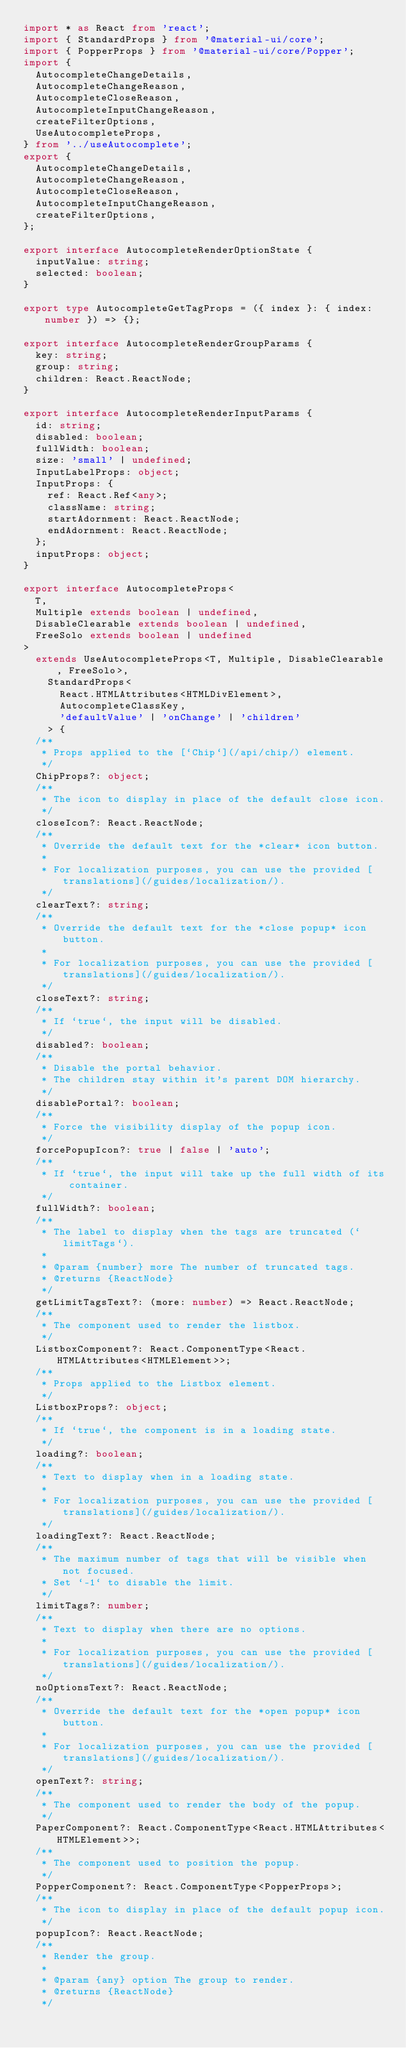Convert code to text. <code><loc_0><loc_0><loc_500><loc_500><_TypeScript_>import * as React from 'react';
import { StandardProps } from '@material-ui/core';
import { PopperProps } from '@material-ui/core/Popper';
import {
  AutocompleteChangeDetails,
  AutocompleteChangeReason,
  AutocompleteCloseReason,
  AutocompleteInputChangeReason,
  createFilterOptions,
  UseAutocompleteProps,
} from '../useAutocomplete';
export {
  AutocompleteChangeDetails,
  AutocompleteChangeReason,
  AutocompleteCloseReason,
  AutocompleteInputChangeReason,
  createFilterOptions,
};

export interface AutocompleteRenderOptionState {
  inputValue: string;
  selected: boolean;
}

export type AutocompleteGetTagProps = ({ index }: { index: number }) => {};

export interface AutocompleteRenderGroupParams {
  key: string;
  group: string;
  children: React.ReactNode;
}

export interface AutocompleteRenderInputParams {
  id: string;
  disabled: boolean;
  fullWidth: boolean;
  size: 'small' | undefined;
  InputLabelProps: object;
  InputProps: {
    ref: React.Ref<any>;
    className: string;
    startAdornment: React.ReactNode;
    endAdornment: React.ReactNode;
  };
  inputProps: object;
}

export interface AutocompleteProps<
  T,
  Multiple extends boolean | undefined,
  DisableClearable extends boolean | undefined,
  FreeSolo extends boolean | undefined
>
  extends UseAutocompleteProps<T, Multiple, DisableClearable, FreeSolo>,
    StandardProps<
      React.HTMLAttributes<HTMLDivElement>,
      AutocompleteClassKey,
      'defaultValue' | 'onChange' | 'children'
    > {
  /**
   * Props applied to the [`Chip`](/api/chip/) element.
   */
  ChipProps?: object;
  /**
   * The icon to display in place of the default close icon.
   */
  closeIcon?: React.ReactNode;
  /**
   * Override the default text for the *clear* icon button.
   *
   * For localization purposes, you can use the provided [translations](/guides/localization/).
   */
  clearText?: string;
  /**
   * Override the default text for the *close popup* icon button.
   *
   * For localization purposes, you can use the provided [translations](/guides/localization/).
   */
  closeText?: string;
  /**
   * If `true`, the input will be disabled.
   */
  disabled?: boolean;
  /**
   * Disable the portal behavior.
   * The children stay within it's parent DOM hierarchy.
   */
  disablePortal?: boolean;
  /**
   * Force the visibility display of the popup icon.
   */
  forcePopupIcon?: true | false | 'auto';
  /**
   * If `true`, the input will take up the full width of its container.
   */
  fullWidth?: boolean;
  /**
   * The label to display when the tags are truncated (`limitTags`).
   *
   * @param {number} more The number of truncated tags.
   * @returns {ReactNode}
   */
  getLimitTagsText?: (more: number) => React.ReactNode;
  /**
   * The component used to render the listbox.
   */
  ListboxComponent?: React.ComponentType<React.HTMLAttributes<HTMLElement>>;
  /**
   * Props applied to the Listbox element.
   */
  ListboxProps?: object;
  /**
   * If `true`, the component is in a loading state.
   */
  loading?: boolean;
  /**
   * Text to display when in a loading state.
   *
   * For localization purposes, you can use the provided [translations](/guides/localization/).
   */
  loadingText?: React.ReactNode;
  /**
   * The maximum number of tags that will be visible when not focused.
   * Set `-1` to disable the limit.
   */
  limitTags?: number;
  /**
   * Text to display when there are no options.
   *
   * For localization purposes, you can use the provided [translations](/guides/localization/).
   */
  noOptionsText?: React.ReactNode;
  /**
   * Override the default text for the *open popup* icon button.
   *
   * For localization purposes, you can use the provided [translations](/guides/localization/).
   */
  openText?: string;
  /**
   * The component used to render the body of the popup.
   */
  PaperComponent?: React.ComponentType<React.HTMLAttributes<HTMLElement>>;
  /**
   * The component used to position the popup.
   */
  PopperComponent?: React.ComponentType<PopperProps>;
  /**
   * The icon to display in place of the default popup icon.
   */
  popupIcon?: React.ReactNode;
  /**
   * Render the group.
   *
   * @param {any} option The group to render.
   * @returns {ReactNode}
   */</code> 